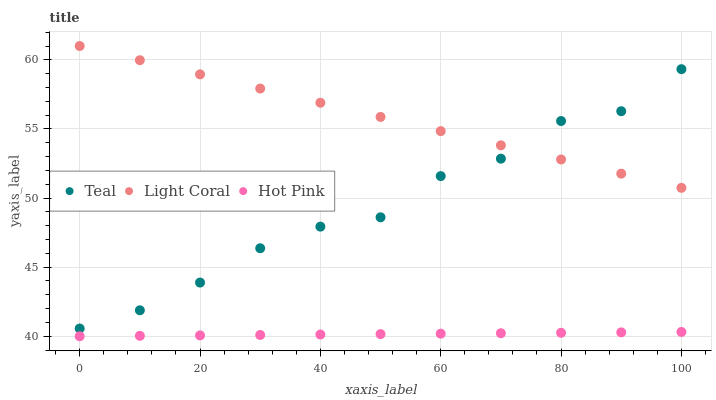Does Hot Pink have the minimum area under the curve?
Answer yes or no. Yes. Does Light Coral have the maximum area under the curve?
Answer yes or no. Yes. Does Teal have the minimum area under the curve?
Answer yes or no. No. Does Teal have the maximum area under the curve?
Answer yes or no. No. Is Light Coral the smoothest?
Answer yes or no. Yes. Is Teal the roughest?
Answer yes or no. Yes. Is Hot Pink the smoothest?
Answer yes or no. No. Is Hot Pink the roughest?
Answer yes or no. No. Does Hot Pink have the lowest value?
Answer yes or no. Yes. Does Teal have the lowest value?
Answer yes or no. No. Does Light Coral have the highest value?
Answer yes or no. Yes. Does Teal have the highest value?
Answer yes or no. No. Is Hot Pink less than Teal?
Answer yes or no. Yes. Is Teal greater than Hot Pink?
Answer yes or no. Yes. Does Teal intersect Light Coral?
Answer yes or no. Yes. Is Teal less than Light Coral?
Answer yes or no. No. Is Teal greater than Light Coral?
Answer yes or no. No. Does Hot Pink intersect Teal?
Answer yes or no. No. 